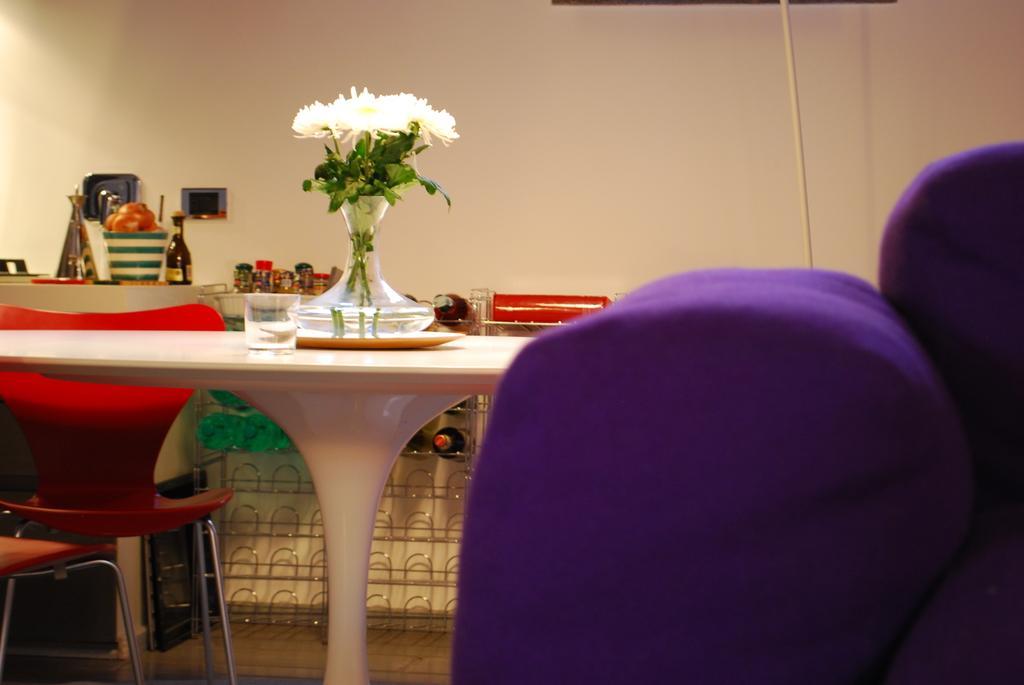In one or two sentences, can you explain what this image depicts? In this picture we can see a table and flower vase and glass on it. these are chairs. On the background of the picture we can see a wall and few bottles and a tub in which where we can see fruits. 